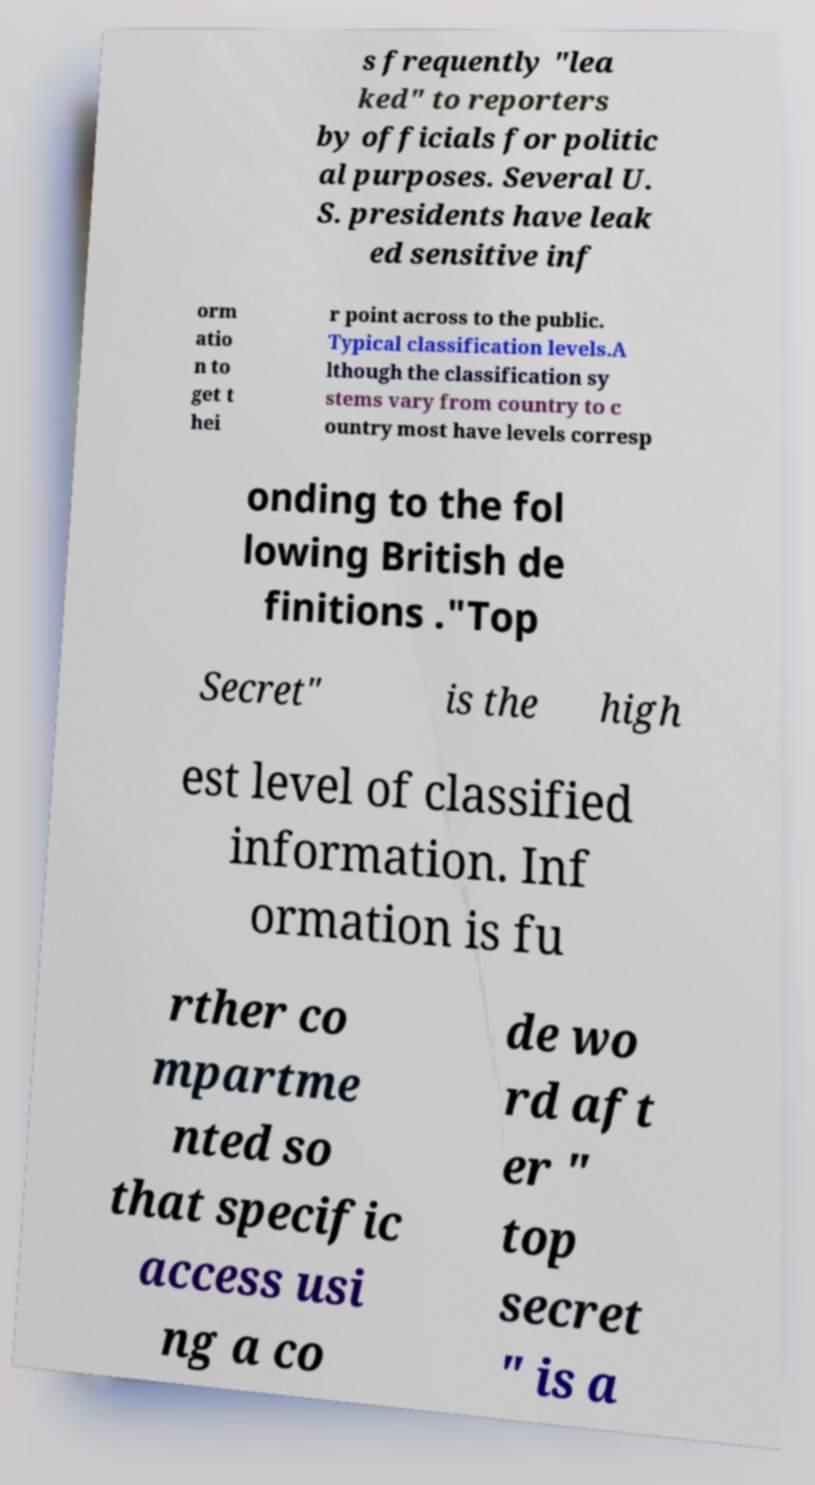I need the written content from this picture converted into text. Can you do that? s frequently "lea ked" to reporters by officials for politic al purposes. Several U. S. presidents have leak ed sensitive inf orm atio n to get t hei r point across to the public. Typical classification levels.A lthough the classification sy stems vary from country to c ountry most have levels corresp onding to the fol lowing British de finitions ."Top Secret" is the high est level of classified information. Inf ormation is fu rther co mpartme nted so that specific access usi ng a co de wo rd aft er " top secret " is a 